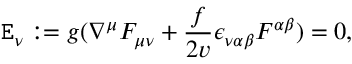<formula> <loc_0><loc_0><loc_500><loc_500>E _ { \nu } \colon = { g } ( \nabla ^ { \mu } F _ { \mu \nu } + \frac { f } { { 2 } v } \epsilon _ { \nu \alpha \beta } F ^ { \alpha \beta } ) = 0 ,</formula> 